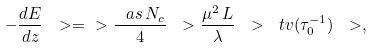<formula> <loc_0><loc_0><loc_500><loc_500>- \frac { d E } { d z } \ > = \ > \frac { \ a s \, N _ { c } } { 4 } \ > \frac { \mu ^ { 2 } \, L } { \lambda } \ > \ t v ( \tau _ { 0 } ^ { - 1 } ) \ > ,</formula> 